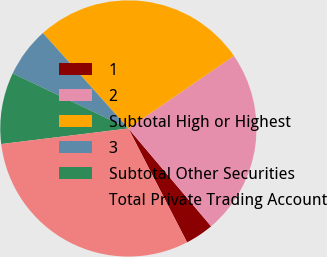Convert chart to OTSL. <chart><loc_0><loc_0><loc_500><loc_500><pie_chart><fcel>1<fcel>2<fcel>Subtotal High or Highest<fcel>3<fcel>Subtotal Other Securities<fcel>Total Private Trading Account<nl><fcel>3.6%<fcel>23.42%<fcel>27.03%<fcel>6.31%<fcel>9.01%<fcel>30.63%<nl></chart> 